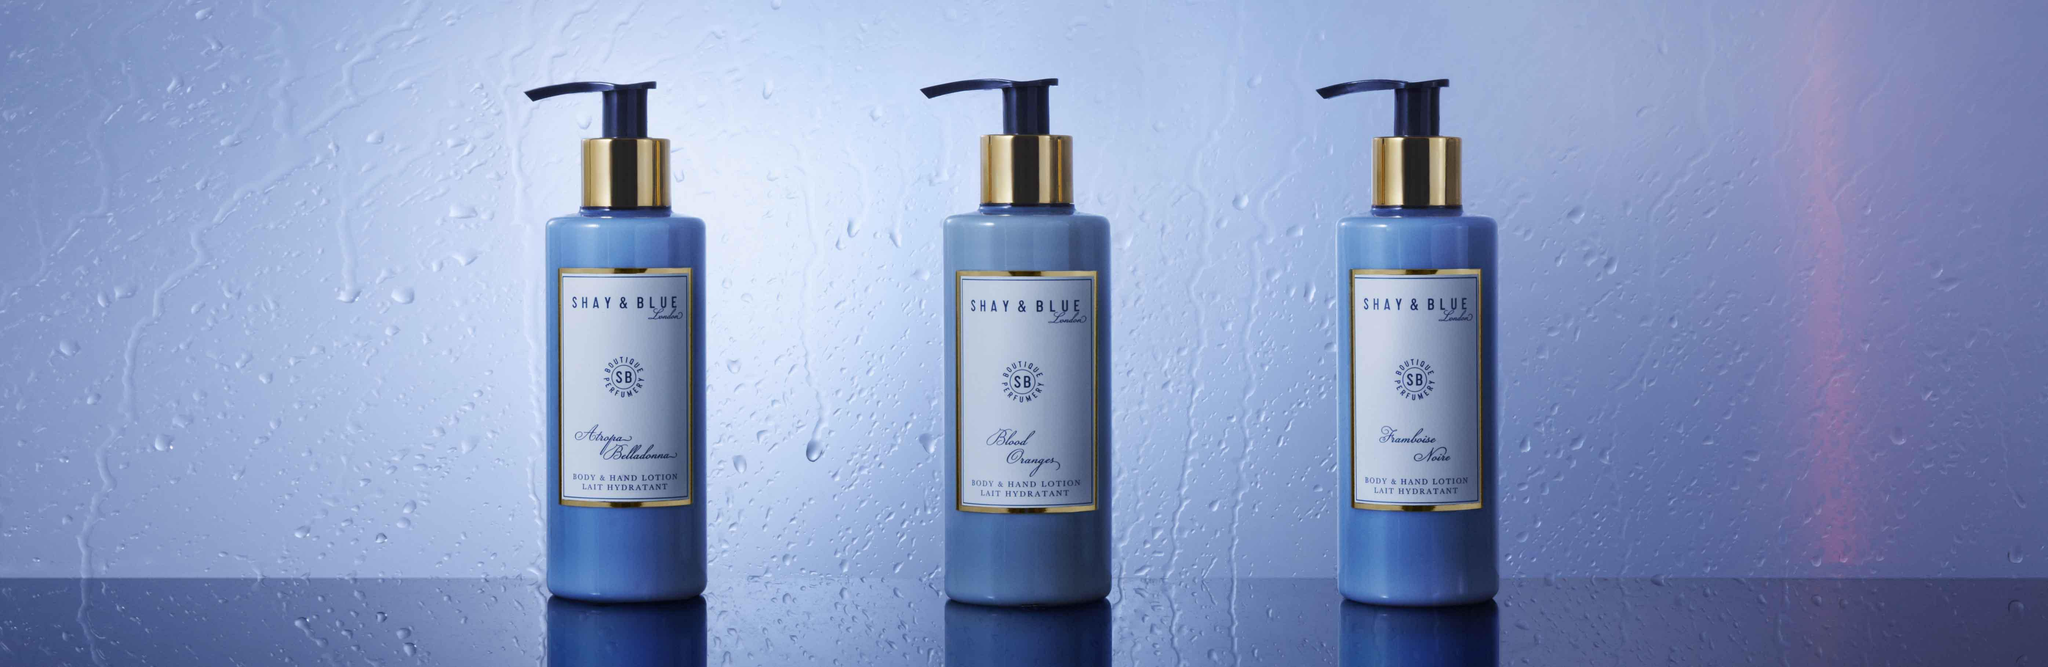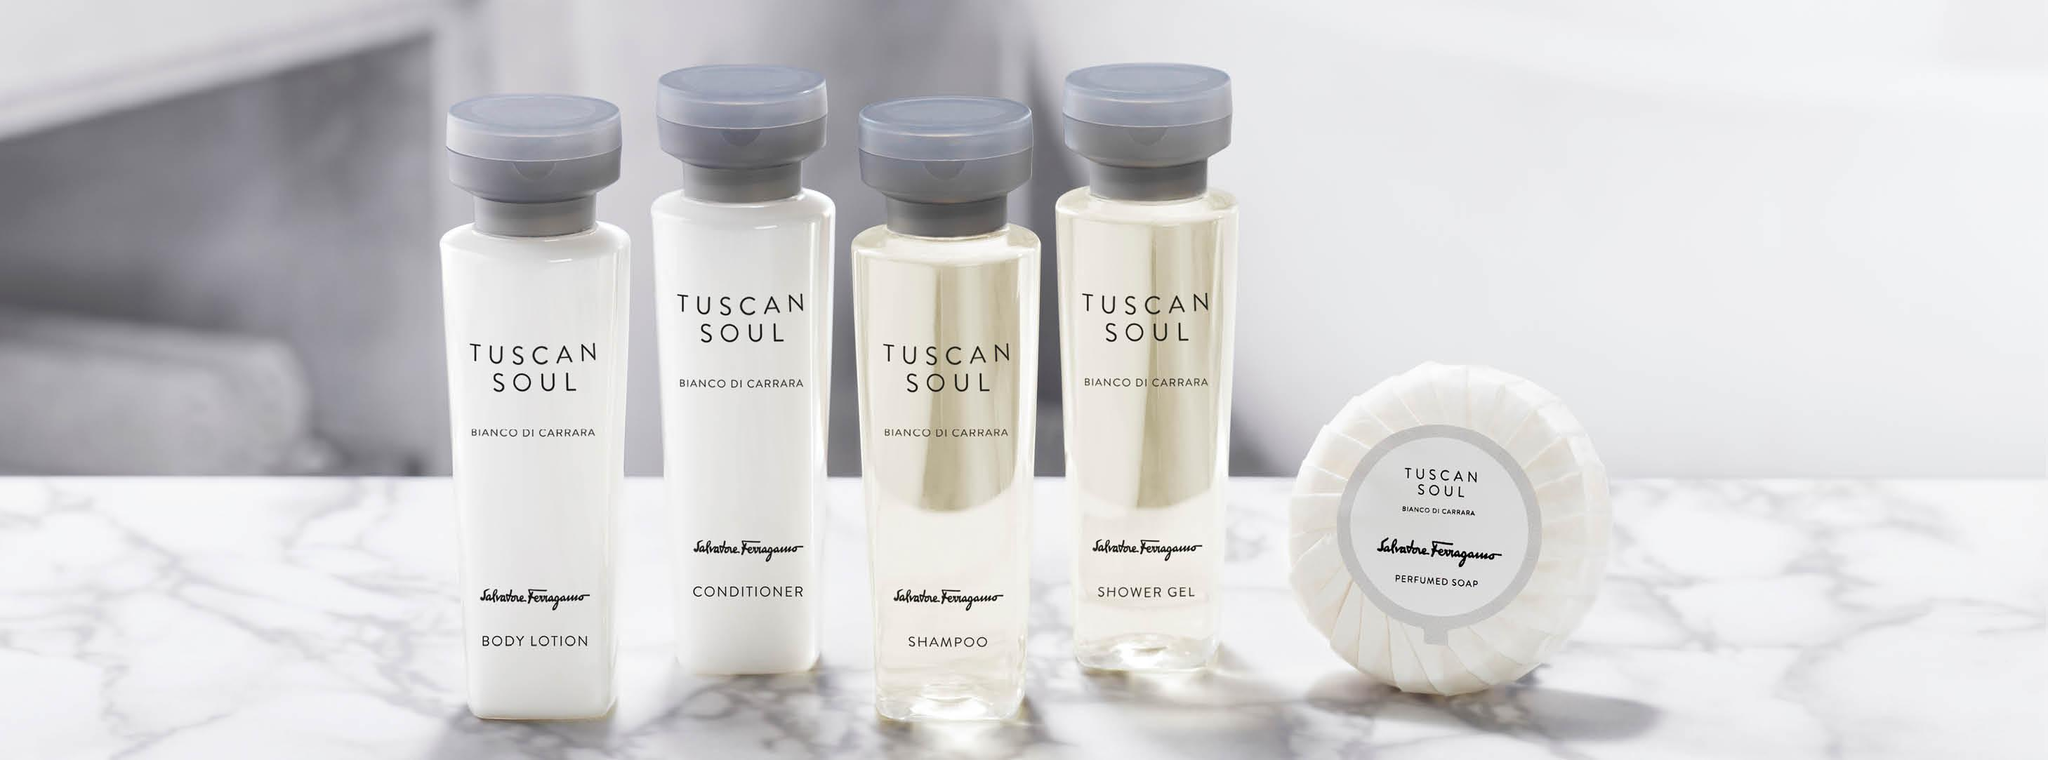The first image is the image on the left, the second image is the image on the right. Analyze the images presented: Is the assertion "One image contains a pump-top bottle, but no image contains more than one pump-top bottle." valid? Answer yes or no. No. The first image is the image on the left, the second image is the image on the right. Assess this claim about the two images: "Some items are laying flat.". Correct or not? Answer yes or no. No. 